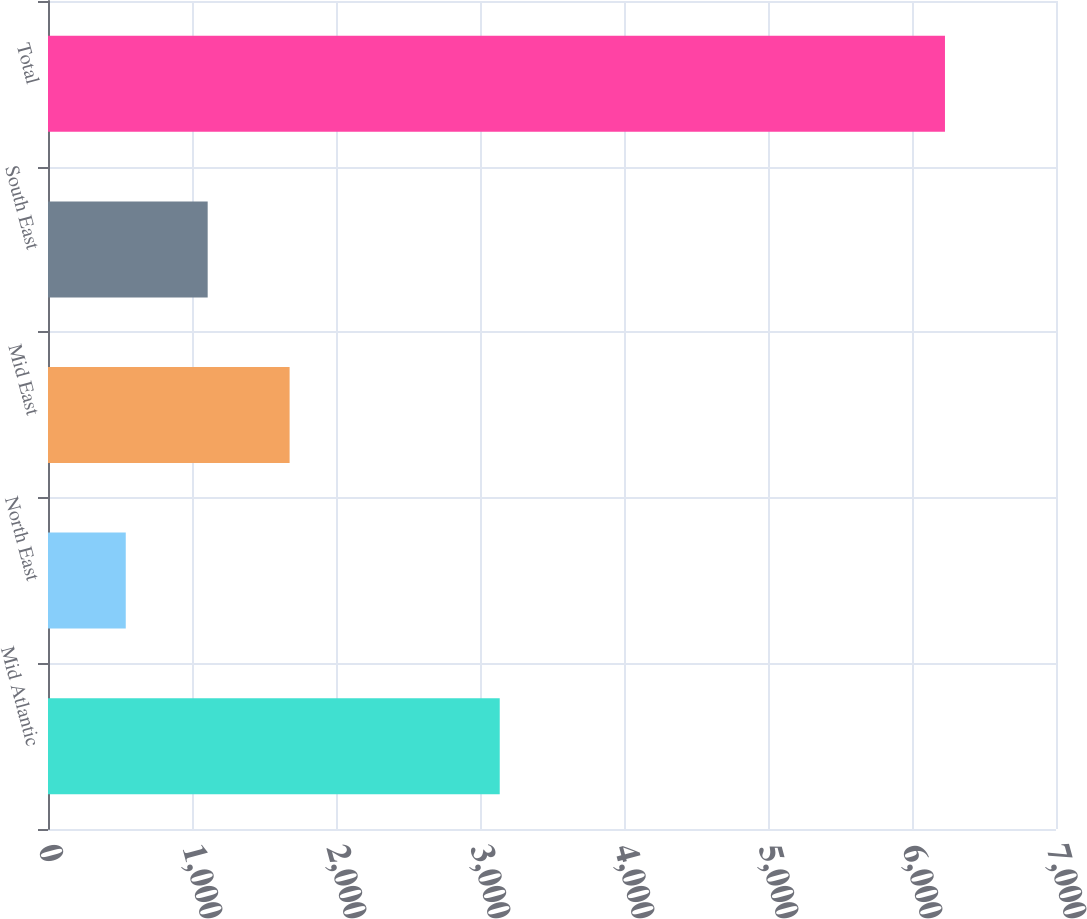Convert chart. <chart><loc_0><loc_0><loc_500><loc_500><bar_chart><fcel>Mid Atlantic<fcel>North East<fcel>Mid East<fcel>South East<fcel>Total<nl><fcel>3137<fcel>540<fcel>1677.8<fcel>1108.9<fcel>6229<nl></chart> 